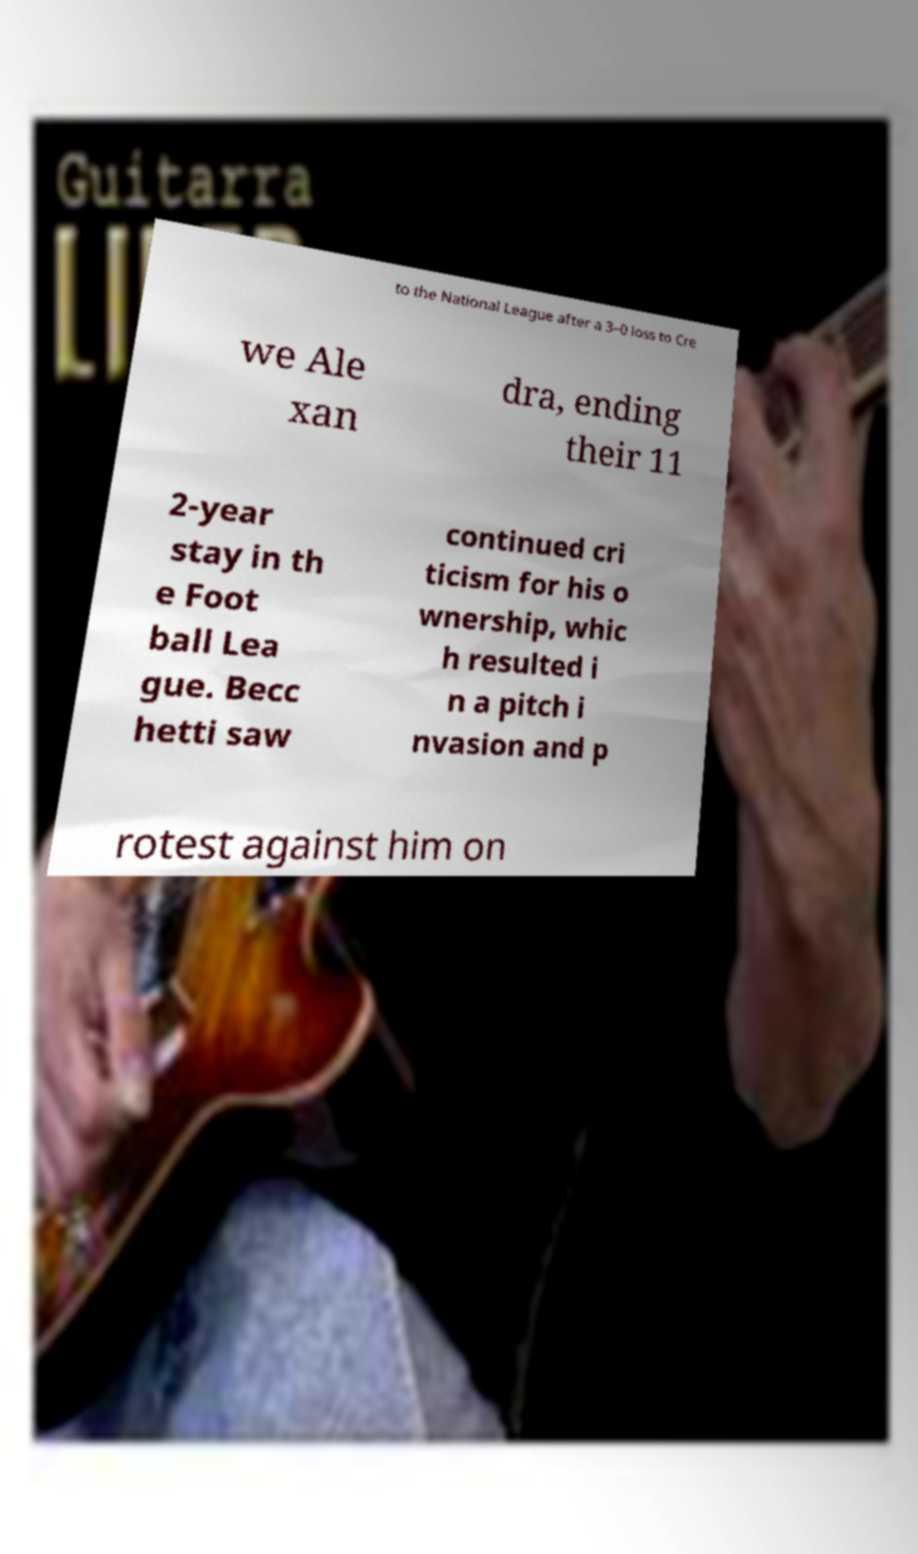There's text embedded in this image that I need extracted. Can you transcribe it verbatim? to the National League after a 3–0 loss to Cre we Ale xan dra, ending their 11 2-year stay in th e Foot ball Lea gue. Becc hetti saw continued cri ticism for his o wnership, whic h resulted i n a pitch i nvasion and p rotest against him on 